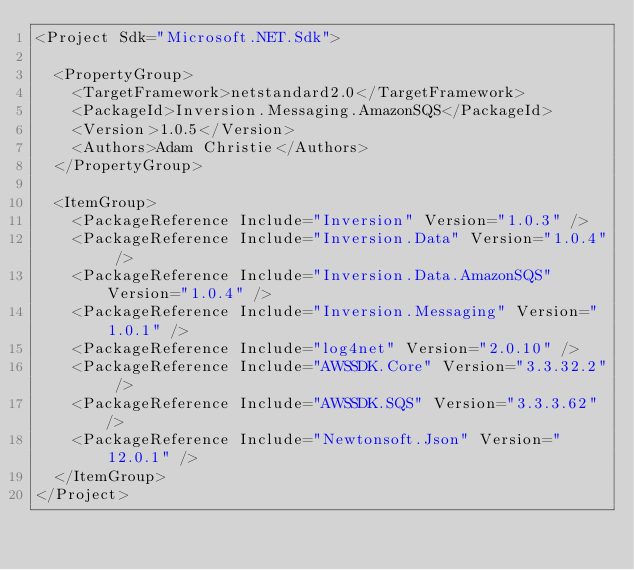Convert code to text. <code><loc_0><loc_0><loc_500><loc_500><_XML_><Project Sdk="Microsoft.NET.Sdk">

  <PropertyGroup>
    <TargetFramework>netstandard2.0</TargetFramework>
    <PackageId>Inversion.Messaging.AmazonSQS</PackageId>
    <Version>1.0.5</Version>
    <Authors>Adam Christie</Authors>
  </PropertyGroup>

  <ItemGroup>
    <PackageReference Include="Inversion" Version="1.0.3" />
    <PackageReference Include="Inversion.Data" Version="1.0.4" />
    <PackageReference Include="Inversion.Data.AmazonSQS" Version="1.0.4" />
    <PackageReference Include="Inversion.Messaging" Version="1.0.1" />
    <PackageReference Include="log4net" Version="2.0.10" />
    <PackageReference Include="AWSSDK.Core" Version="3.3.32.2" />
    <PackageReference Include="AWSSDK.SQS" Version="3.3.3.62" />
    <PackageReference Include="Newtonsoft.Json" Version="12.0.1" />
  </ItemGroup>
</Project>
</code> 